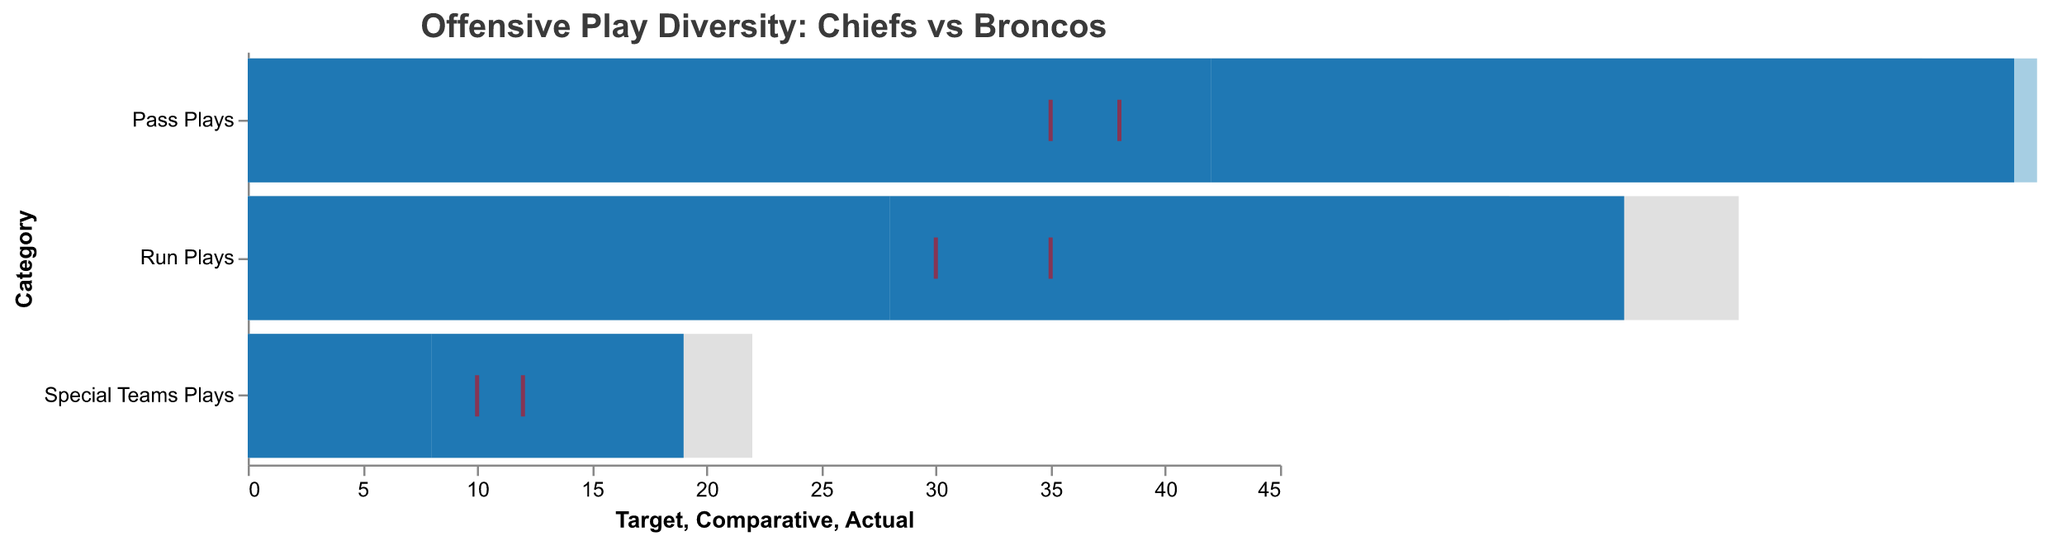How many run plays did each team actually execute? The "Actual" bar in the Run Plays category shows 28 for the Chiefs and 32 for the Broncos.
Answer: Chiefs: 28, Broncos: 32 Did the Chiefs reach their target for pass plays? The target for the Chiefs' pass plays is indicated by a tick mark at 35, and the actual value is shown as 42, which is greater than the target.
Answer: Yes How do the Broncos' actual special teams plays compare to their comparative value? The actual number of special teams plays for the Broncos is 11, while the comparative value is 9. The actual value is higher than the comparative.
Answer: The Broncos' actual special teams plays are higher Which team has a higher comparative value for pass plays? The comparative value for pass plays is shown as 38 for the Chiefs and 40 for the Broncos.
Answer: Broncos By how much did the Chiefs exceed their target for run plays? The target for the Chiefs' run plays is 30, whereas the actual count is 28. The Chiefs did not exceed their target but rather fell short by 2.
Answer: The Chiefs did not exceed; they fell short by 2 What's the difference between the actual and comparative number of special teams plays for the Chiefs? The actual number of special teams plays for the Chiefs is 8, and the comparative value is 10. Subtracting these (10 - 8) gives a difference of 2.
Answer: 2 Which team is closer to its target for special teams plays? For the Chiefs, the difference between actual (8) and target (12) is 4. For the Broncos, the difference between actual (11) and target (10) is 1. The Broncos are closer to their target.
Answer: Broncos What can you infer about the Chiefs' offensive focus based on play diversity? The Chiefs have more plays in the pass category (42) than the run category (28) or special teams (8), suggesting a greater focus on passing plays.
Answer: Greater focus on passing plays How many total plays (run, pass, special teams) did the Broncos actually execute? Summing up the actual values for Broncos: Run (32) + Pass (35) + Special Teams (11) equals 78 total plays.
Answer: 78 